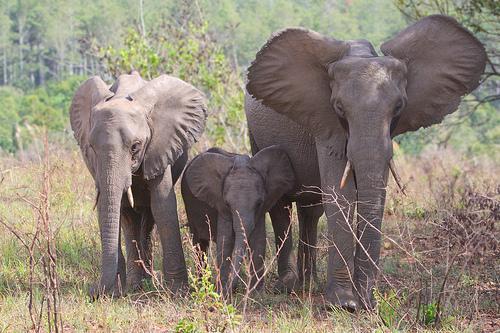How many are they?
Give a very brief answer. 3. 